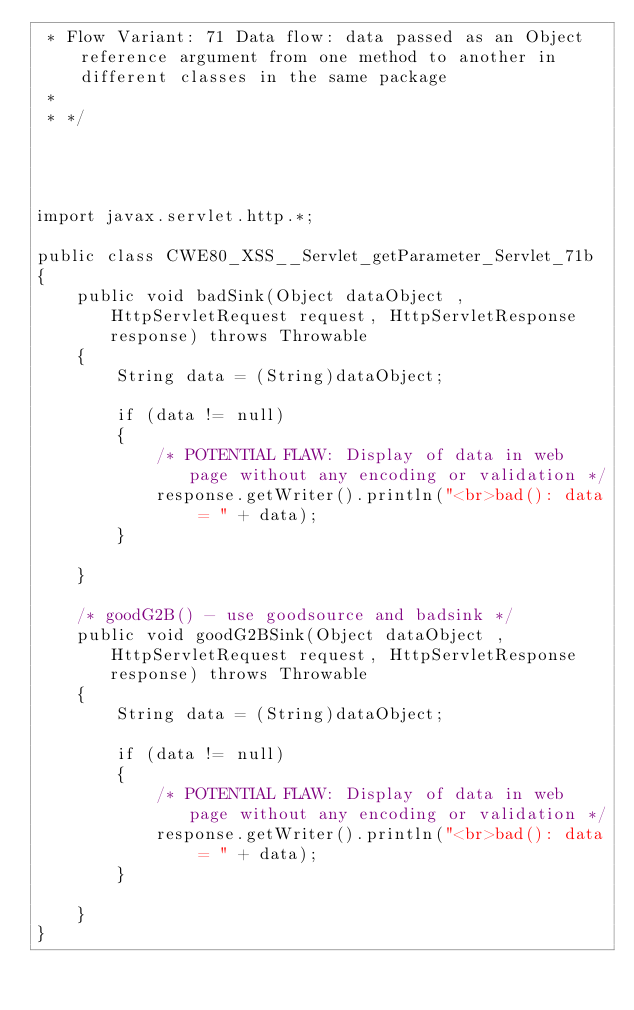<code> <loc_0><loc_0><loc_500><loc_500><_Java_> * Flow Variant: 71 Data flow: data passed as an Object reference argument from one method to another in different classes in the same package
 *
 * */




import javax.servlet.http.*;

public class CWE80_XSS__Servlet_getParameter_Servlet_71b
{
    public void badSink(Object dataObject , HttpServletRequest request, HttpServletResponse response) throws Throwable
    {
        String data = (String)dataObject;

        if (data != null)
        {
            /* POTENTIAL FLAW: Display of data in web page without any encoding or validation */
            response.getWriter().println("<br>bad(): data = " + data);
        }

    }

    /* goodG2B() - use goodsource and badsink */
    public void goodG2BSink(Object dataObject , HttpServletRequest request, HttpServletResponse response) throws Throwable
    {
        String data = (String)dataObject;

        if (data != null)
        {
            /* POTENTIAL FLAW: Display of data in web page without any encoding or validation */
            response.getWriter().println("<br>bad(): data = " + data);
        }

    }
}
</code> 